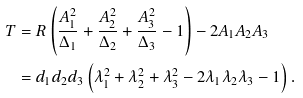Convert formula to latex. <formula><loc_0><loc_0><loc_500><loc_500>T & = R \left ( \frac { A _ { 1 } ^ { 2 } } { \Delta _ { 1 } } + \frac { A _ { 2 } ^ { 2 } } { \Delta _ { 2 } } + \frac { A _ { 3 } ^ { 2 } } { \Delta _ { 3 } } - 1 \right ) - 2 A _ { 1 } A _ { 2 } A _ { 3 } \\ & = d _ { 1 } d _ { 2 } d _ { 3 } \left ( \lambda _ { 1 } ^ { 2 } + \lambda _ { 2 } ^ { 2 } + \lambda _ { 3 } ^ { 2 } - 2 \lambda _ { 1 } \lambda _ { 2 } \lambda _ { 3 } - 1 \right ) .</formula> 